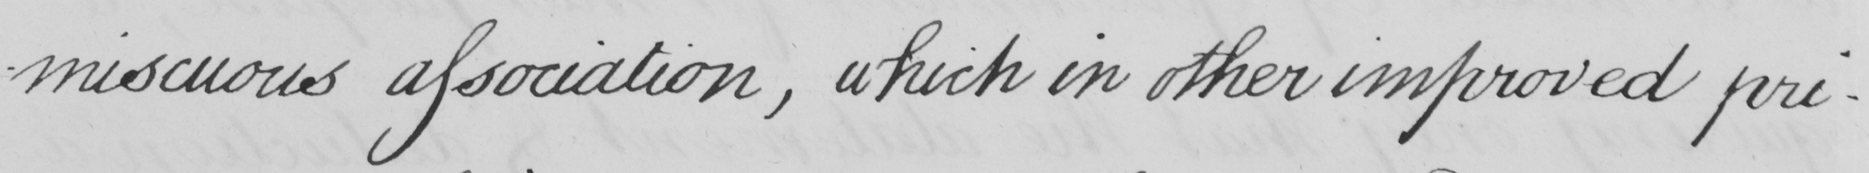What text is written in this handwritten line? -miscuous association, which in other improved pri- 